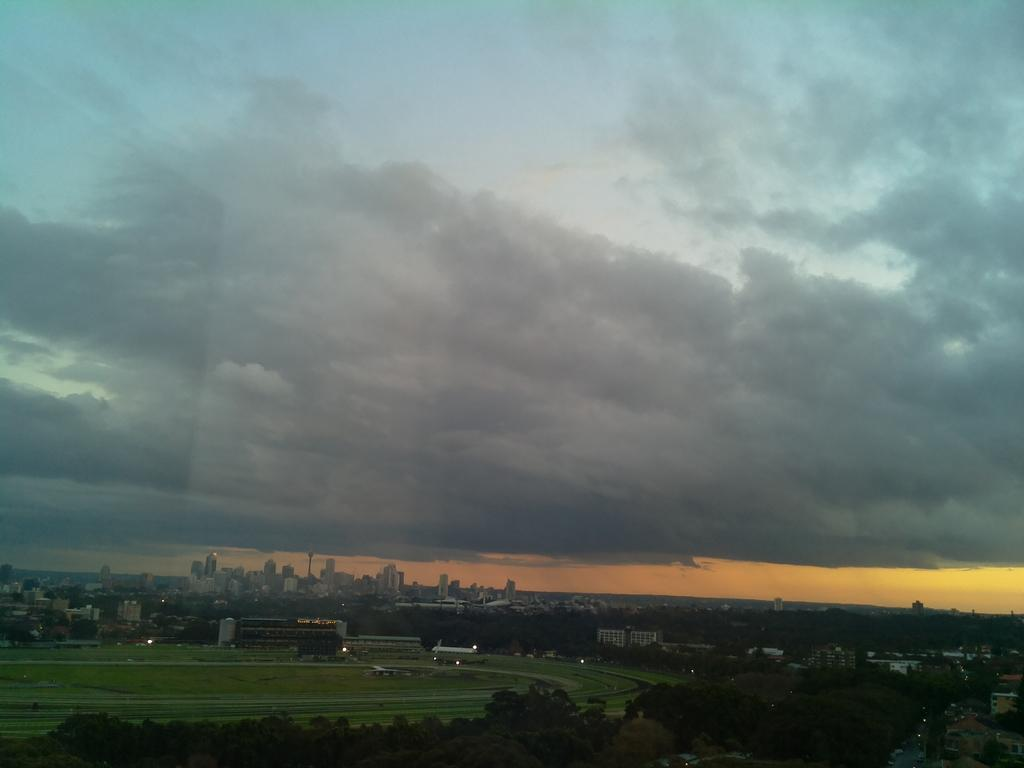What type of structures can be seen in the image? There are buildings in the image. What type of vegetation is present in the image? There is grass and trees in the image. What part of the natural environment is visible in the image? The sky is visible in the image. What can be observed in the sky in the image? Clouds are present in the image. How would you describe the lighting in the image? The image appears to be slightly dark. What type of kitten can be seen playing with a sheet in the image? There is no kitten or sheet present in the image; the image features buildings, grass, trees, sky, and clouds. What smell can be detected in the image? There is no mention of smell in the image, as it is a visual representation. 